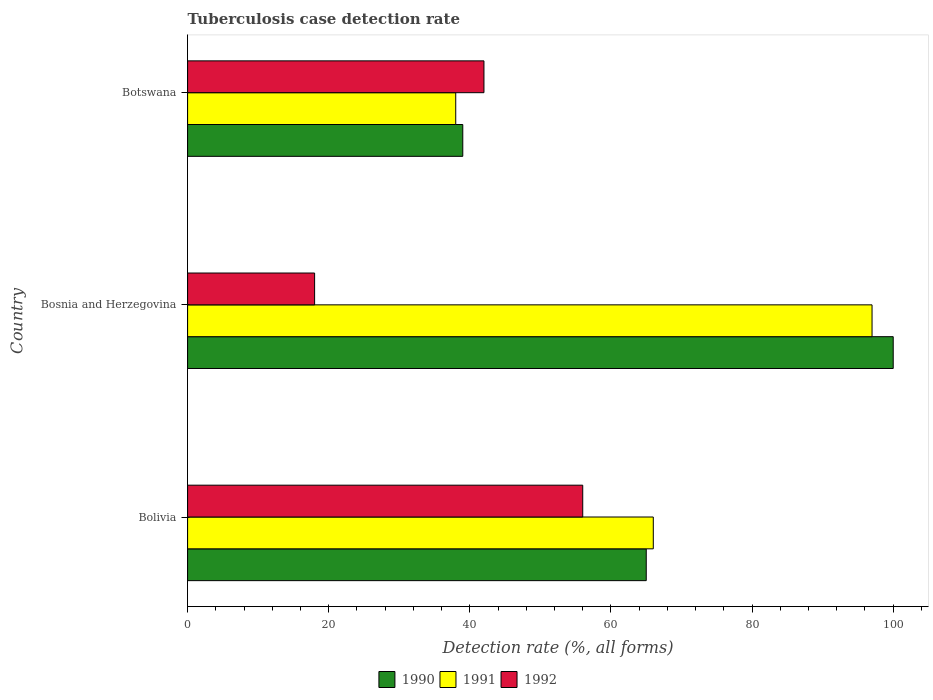How many groups of bars are there?
Provide a succinct answer. 3. How many bars are there on the 2nd tick from the bottom?
Your response must be concise. 3. What is the label of the 2nd group of bars from the top?
Offer a very short reply. Bosnia and Herzegovina. What is the tuberculosis case detection rate in in 1990 in Botswana?
Make the answer very short. 39. Across all countries, what is the maximum tuberculosis case detection rate in in 1992?
Your answer should be very brief. 56. Across all countries, what is the minimum tuberculosis case detection rate in in 1992?
Provide a short and direct response. 18. In which country was the tuberculosis case detection rate in in 1990 maximum?
Provide a short and direct response. Bosnia and Herzegovina. In which country was the tuberculosis case detection rate in in 1991 minimum?
Your answer should be compact. Botswana. What is the total tuberculosis case detection rate in in 1992 in the graph?
Offer a terse response. 116. What is the difference between the tuberculosis case detection rate in in 1992 in Bosnia and Herzegovina and that in Botswana?
Your answer should be very brief. -24. What is the difference between the tuberculosis case detection rate in in 1990 in Bolivia and the tuberculosis case detection rate in in 1991 in Bosnia and Herzegovina?
Your answer should be very brief. -32. What is the average tuberculosis case detection rate in in 1990 per country?
Your answer should be very brief. 68. What is the ratio of the tuberculosis case detection rate in in 1992 in Bolivia to that in Bosnia and Herzegovina?
Your answer should be compact. 3.11. Is the difference between the tuberculosis case detection rate in in 1992 in Bosnia and Herzegovina and Botswana greater than the difference between the tuberculosis case detection rate in in 1990 in Bosnia and Herzegovina and Botswana?
Give a very brief answer. No. Is the sum of the tuberculosis case detection rate in in 1990 in Bolivia and Botswana greater than the maximum tuberculosis case detection rate in in 1991 across all countries?
Provide a short and direct response. Yes. What does the 1st bar from the bottom in Botswana represents?
Offer a terse response. 1990. Are all the bars in the graph horizontal?
Keep it short and to the point. Yes. What is the difference between two consecutive major ticks on the X-axis?
Your response must be concise. 20. Does the graph contain any zero values?
Provide a succinct answer. No. Where does the legend appear in the graph?
Provide a succinct answer. Bottom center. What is the title of the graph?
Keep it short and to the point. Tuberculosis case detection rate. What is the label or title of the X-axis?
Give a very brief answer. Detection rate (%, all forms). What is the label or title of the Y-axis?
Your answer should be compact. Country. What is the Detection rate (%, all forms) of 1990 in Bolivia?
Offer a very short reply. 65. What is the Detection rate (%, all forms) of 1991 in Bosnia and Herzegovina?
Ensure brevity in your answer.  97. What is the Detection rate (%, all forms) of 1992 in Bosnia and Herzegovina?
Provide a short and direct response. 18. What is the Detection rate (%, all forms) of 1991 in Botswana?
Offer a very short reply. 38. Across all countries, what is the maximum Detection rate (%, all forms) of 1990?
Provide a short and direct response. 100. Across all countries, what is the maximum Detection rate (%, all forms) in 1991?
Offer a terse response. 97. Across all countries, what is the maximum Detection rate (%, all forms) in 1992?
Offer a terse response. 56. Across all countries, what is the minimum Detection rate (%, all forms) of 1990?
Your answer should be very brief. 39. Across all countries, what is the minimum Detection rate (%, all forms) of 1991?
Provide a succinct answer. 38. Across all countries, what is the minimum Detection rate (%, all forms) in 1992?
Offer a very short reply. 18. What is the total Detection rate (%, all forms) in 1990 in the graph?
Make the answer very short. 204. What is the total Detection rate (%, all forms) in 1991 in the graph?
Keep it short and to the point. 201. What is the total Detection rate (%, all forms) in 1992 in the graph?
Ensure brevity in your answer.  116. What is the difference between the Detection rate (%, all forms) in 1990 in Bolivia and that in Bosnia and Herzegovina?
Your answer should be compact. -35. What is the difference between the Detection rate (%, all forms) of 1991 in Bolivia and that in Bosnia and Herzegovina?
Keep it short and to the point. -31. What is the difference between the Detection rate (%, all forms) in 1990 in Bolivia and that in Botswana?
Provide a succinct answer. 26. What is the difference between the Detection rate (%, all forms) in 1991 in Bolivia and that in Botswana?
Provide a succinct answer. 28. What is the difference between the Detection rate (%, all forms) of 1992 in Bolivia and that in Botswana?
Ensure brevity in your answer.  14. What is the difference between the Detection rate (%, all forms) in 1992 in Bosnia and Herzegovina and that in Botswana?
Offer a terse response. -24. What is the difference between the Detection rate (%, all forms) in 1990 in Bolivia and the Detection rate (%, all forms) in 1991 in Bosnia and Herzegovina?
Your answer should be compact. -32. What is the difference between the Detection rate (%, all forms) of 1990 in Bolivia and the Detection rate (%, all forms) of 1992 in Bosnia and Herzegovina?
Your response must be concise. 47. What is the difference between the Detection rate (%, all forms) in 1990 in Bolivia and the Detection rate (%, all forms) in 1991 in Botswana?
Provide a short and direct response. 27. What is the average Detection rate (%, all forms) of 1992 per country?
Ensure brevity in your answer.  38.67. What is the difference between the Detection rate (%, all forms) of 1990 and Detection rate (%, all forms) of 1991 in Bolivia?
Give a very brief answer. -1. What is the difference between the Detection rate (%, all forms) in 1990 and Detection rate (%, all forms) in 1992 in Bosnia and Herzegovina?
Make the answer very short. 82. What is the difference between the Detection rate (%, all forms) in 1991 and Detection rate (%, all forms) in 1992 in Bosnia and Herzegovina?
Your response must be concise. 79. What is the difference between the Detection rate (%, all forms) in 1990 and Detection rate (%, all forms) in 1992 in Botswana?
Give a very brief answer. -3. What is the difference between the Detection rate (%, all forms) in 1991 and Detection rate (%, all forms) in 1992 in Botswana?
Keep it short and to the point. -4. What is the ratio of the Detection rate (%, all forms) in 1990 in Bolivia to that in Bosnia and Herzegovina?
Make the answer very short. 0.65. What is the ratio of the Detection rate (%, all forms) in 1991 in Bolivia to that in Bosnia and Herzegovina?
Provide a succinct answer. 0.68. What is the ratio of the Detection rate (%, all forms) in 1992 in Bolivia to that in Bosnia and Herzegovina?
Offer a terse response. 3.11. What is the ratio of the Detection rate (%, all forms) of 1990 in Bolivia to that in Botswana?
Offer a very short reply. 1.67. What is the ratio of the Detection rate (%, all forms) of 1991 in Bolivia to that in Botswana?
Offer a very short reply. 1.74. What is the ratio of the Detection rate (%, all forms) in 1990 in Bosnia and Herzegovina to that in Botswana?
Offer a very short reply. 2.56. What is the ratio of the Detection rate (%, all forms) of 1991 in Bosnia and Herzegovina to that in Botswana?
Your answer should be very brief. 2.55. What is the ratio of the Detection rate (%, all forms) of 1992 in Bosnia and Herzegovina to that in Botswana?
Ensure brevity in your answer.  0.43. What is the difference between the highest and the second highest Detection rate (%, all forms) in 1991?
Offer a very short reply. 31. What is the difference between the highest and the second highest Detection rate (%, all forms) of 1992?
Ensure brevity in your answer.  14. What is the difference between the highest and the lowest Detection rate (%, all forms) in 1992?
Provide a succinct answer. 38. 